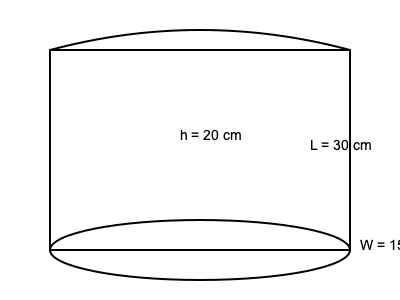You're designing a new eco-friendly container for your zero-waste product line. The container has a curved top, straight sides, and an elliptical base. If the height (h) is 20 cm, length (L) is 30 cm, and width (W) is 15 cm, estimate the volume of the container in liters. Assume the curved top adds approximately 10% to the volume of a rectangular prism with the same dimensions. Let's approach this step-by-step:

1) First, calculate the volume of a rectangular prism with the given dimensions:
   $V_{prism} = L \times W \times h$
   $V_{prism} = 30 \text{ cm} \times 15 \text{ cm} \times 20 \text{ cm} = 9000 \text{ cm}^3$

2) The curved top adds approximately 10% to this volume:
   $V_{additional} = 10\% \times V_{prism} = 0.1 \times 9000 \text{ cm}^3 = 900 \text{ cm}^3$

3) Total estimated volume:
   $V_{total} = V_{prism} + V_{additional} = 9000 \text{ cm}^3 + 900 \text{ cm}^3 = 9900 \text{ cm}^3$

4) Convert cubic centimeters to liters:
   $1 \text{ L} = 1000 \text{ cm}^3$
   $V_{liters} = \frac{9900 \text{ cm}^3}{1000 \text{ cm}^3/L} = 9.9 \text{ L}$

Therefore, the estimated volume of the container is 9.9 liters.
Answer: 9.9 L 